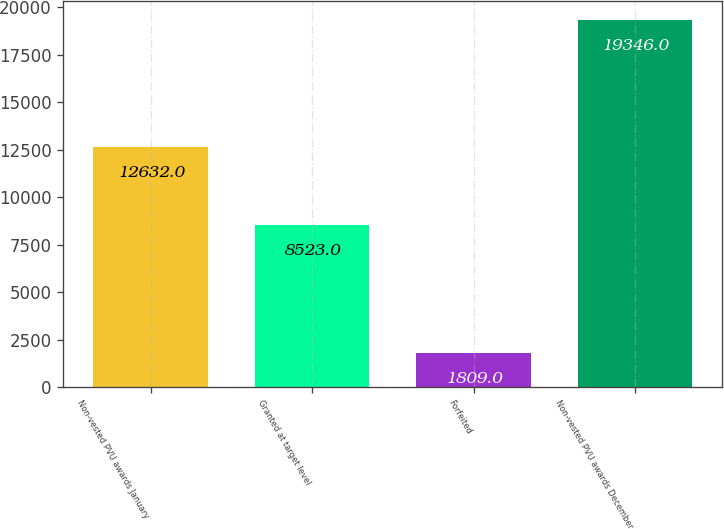<chart> <loc_0><loc_0><loc_500><loc_500><bar_chart><fcel>Non-vested PVU awards January<fcel>Granted at target level<fcel>Forfeited<fcel>Non-vested PVU awards December<nl><fcel>12632<fcel>8523<fcel>1809<fcel>19346<nl></chart> 